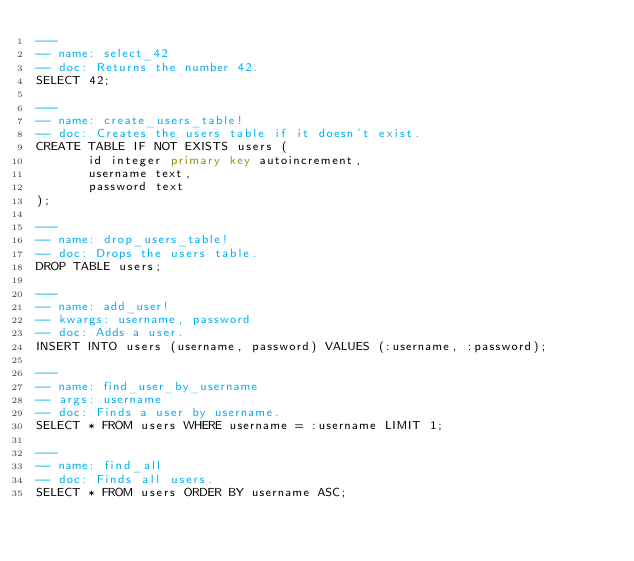Convert code to text. <code><loc_0><loc_0><loc_500><loc_500><_SQL_>---
-- name: select_42
-- doc: Returns the number 42.
SELECT 42;

---
-- name: create_users_table!
-- doc: Creates the users table if it doesn't exist.
CREATE TABLE IF NOT EXISTS users (
       id integer primary key autoincrement,
       username text,
       password text
);

---
-- name: drop_users_table!
-- doc: Drops the users table.
DROP TABLE users;

---
-- name: add_user!
-- kwargs: username, password
-- doc: Adds a user.
INSERT INTO users (username, password) VALUES (:username, :password);

---
-- name: find_user_by_username
-- args: username
-- doc: Finds a user by username.
SELECT * FROM users WHERE username = :username LIMIT 1;

---
-- name: find_all
-- doc: Finds all users.
SELECT * FROM users ORDER BY username ASC;
</code> 